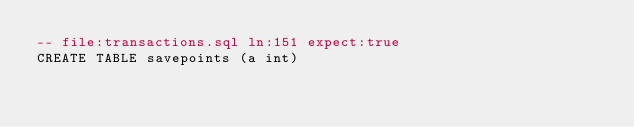<code> <loc_0><loc_0><loc_500><loc_500><_SQL_>-- file:transactions.sql ln:151 expect:true
CREATE TABLE savepoints (a int)
</code> 